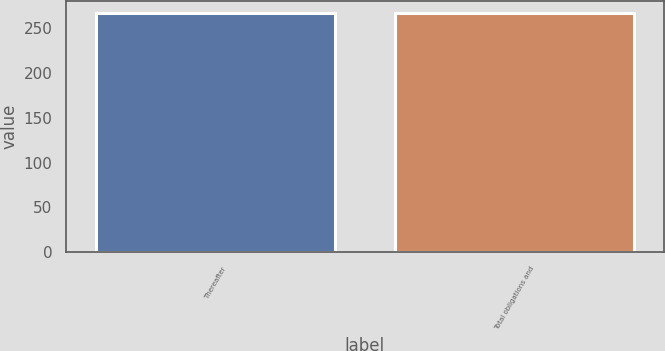Convert chart. <chart><loc_0><loc_0><loc_500><loc_500><bar_chart><fcel>Thereafter<fcel>Total obligations and<nl><fcel>267.1<fcel>267.2<nl></chart> 